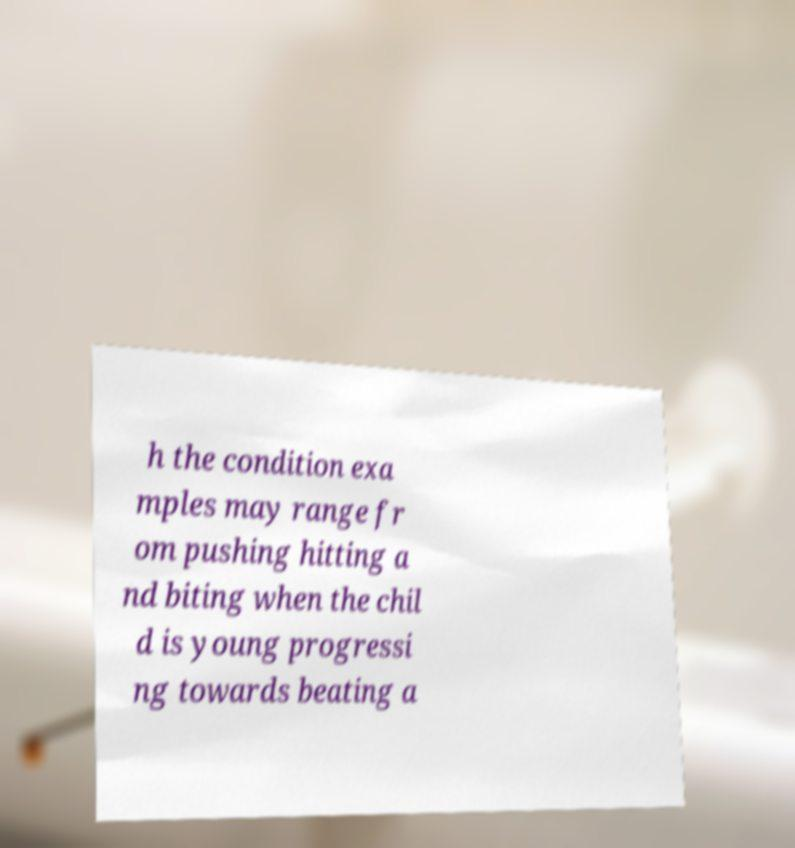Please read and relay the text visible in this image. What does it say? h the condition exa mples may range fr om pushing hitting a nd biting when the chil d is young progressi ng towards beating a 